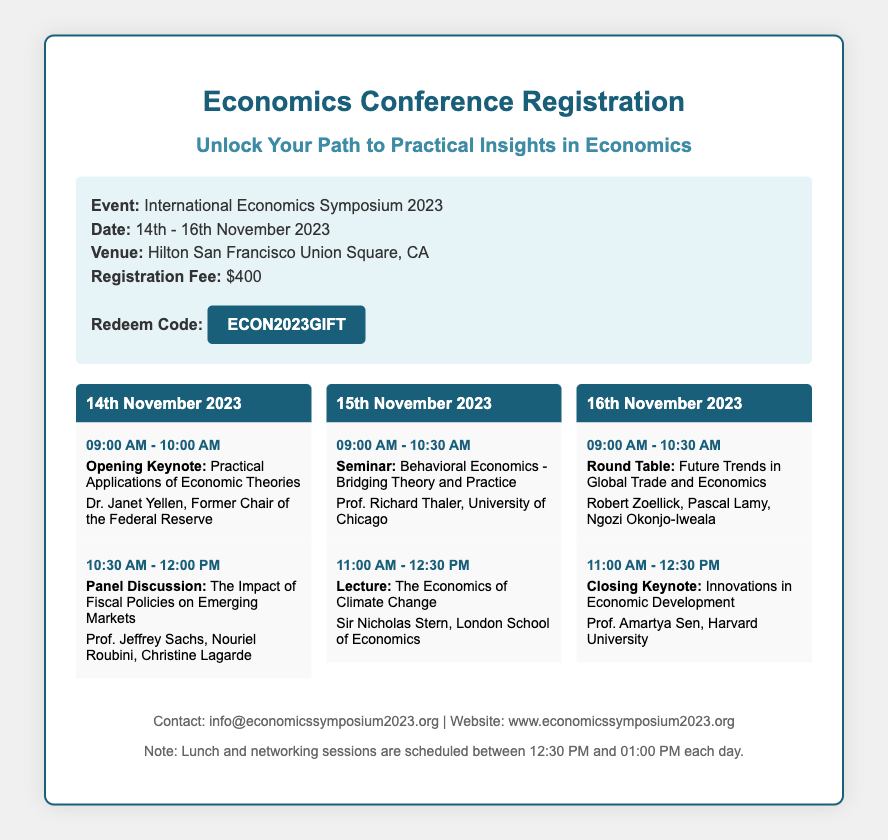What is the event title? The title of the event is mentioned prominently in the document, which is "International Economics Symposium 2023".
Answer: International Economics Symposium 2023 What are the dates of the conference? The dates specified for the conference are included in the details section of the document.
Answer: 14th - 16th November 2023 What is the registration fee? The registration fee is explicitly stated in the details section of the voucher as a monetary value.
Answer: $400 Who is the opening keynote speaker? The opening keynote speaker is named in the schedule for the first day of the conference along with their title.
Answer: Dr. Janet Yellen What time does the seminar on Behavioral Economics start? The start time for the seminar is provided in the schedule for the second day of the conference.
Answer: 09:00 AM How many days does the conference run? The total number of days can be deduced from the start and end dates given in the document.
Answer: 3 days What is the redeem code for the voucher? The redeem code is given in the details section of the document for participants to use.
Answer: ECON2023GIFT Which university is Prof. Richard Thaler associated with? The university linked with Prof. Richard Thaler is mentioned in the context of his seminar on the second day.
Answer: University of Chicago What event is scheduled immediately after lunch each day? The document notes that lunch and networking sessions occur, and the schedule includes events occurring before and after this period.
Answer: Lecture, Round Table, Closing Keynote Who is giving the closing keynote address? The closing keynote speaker is stated in the schedule for the last day of the conference.
Answer: Prof. Amartya Sen 